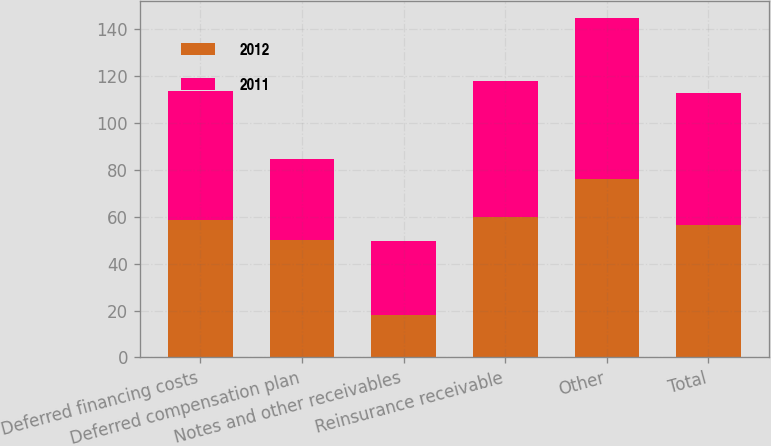<chart> <loc_0><loc_0><loc_500><loc_500><stacked_bar_chart><ecel><fcel>Deferred financing costs<fcel>Deferred compensation plan<fcel>Notes and other receivables<fcel>Reinsurance receivable<fcel>Other<fcel>Total<nl><fcel>2012<fcel>58.8<fcel>49.9<fcel>17.9<fcel>59.7<fcel>76.1<fcel>56.3<nl><fcel>2011<fcel>54.6<fcel>34.5<fcel>31.6<fcel>58<fcel>68.6<fcel>56.3<nl></chart> 